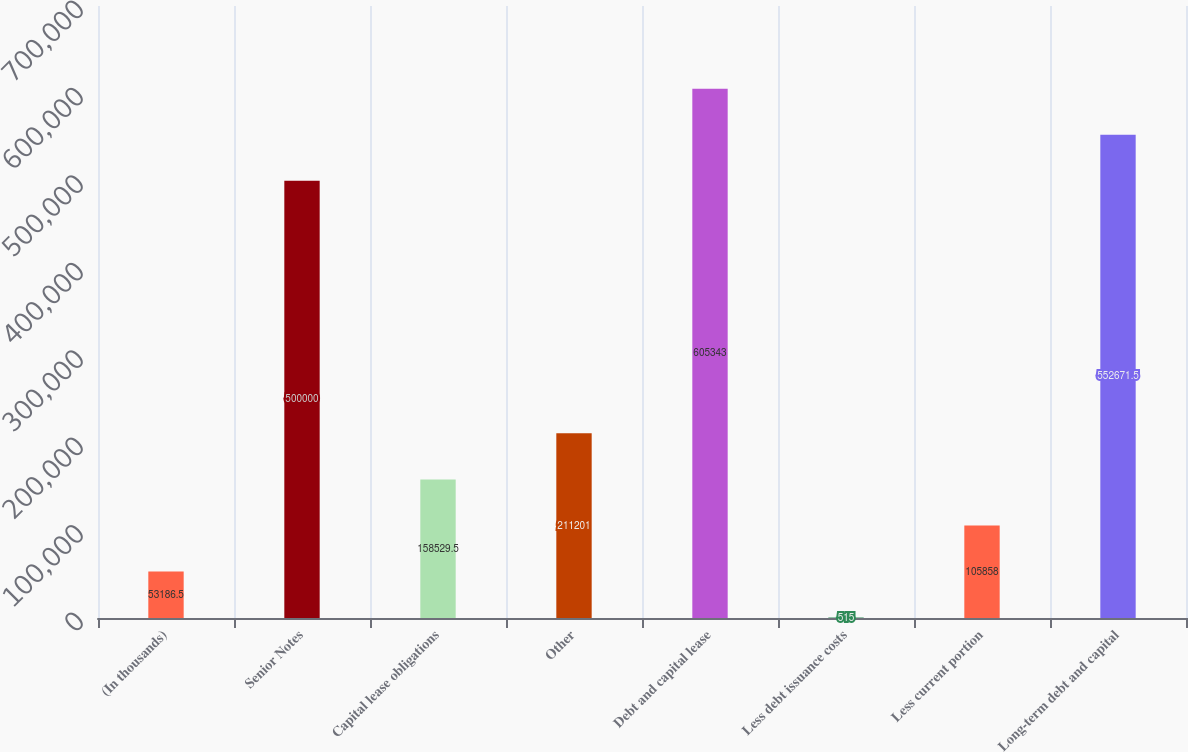<chart> <loc_0><loc_0><loc_500><loc_500><bar_chart><fcel>(In thousands)<fcel>Senior Notes<fcel>Capital lease obligations<fcel>Other<fcel>Debt and capital lease<fcel>Less debt issuance costs<fcel>Less current portion<fcel>Long-term debt and capital<nl><fcel>53186.5<fcel>500000<fcel>158530<fcel>211201<fcel>605343<fcel>515<fcel>105858<fcel>552672<nl></chart> 